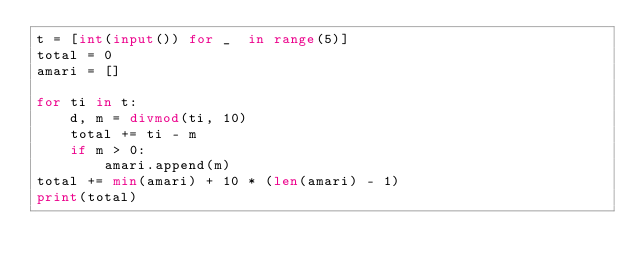Convert code to text. <code><loc_0><loc_0><loc_500><loc_500><_Python_>t = [int(input()) for _  in range(5)]
total = 0
amari = []

for ti in t:
    d, m = divmod(ti, 10)
    total += ti - m
    if m > 0:
        amari.append(m)
total += min(amari) + 10 * (len(amari) - 1)
print(total)</code> 